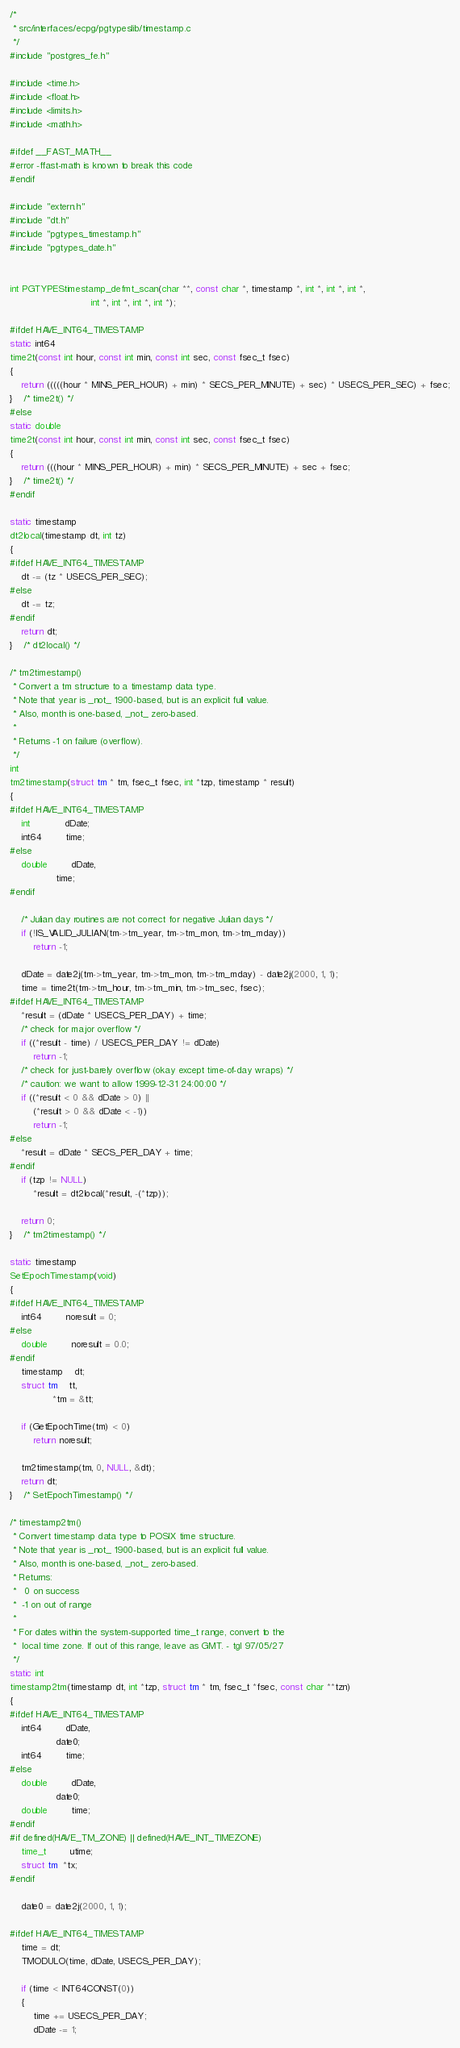<code> <loc_0><loc_0><loc_500><loc_500><_C_>/*
 * src/interfaces/ecpg/pgtypeslib/timestamp.c
 */
#include "postgres_fe.h"

#include <time.h>
#include <float.h>
#include <limits.h>
#include <math.h>

#ifdef __FAST_MATH__
#error -ffast-math is known to break this code
#endif

#include "extern.h"
#include "dt.h"
#include "pgtypes_timestamp.h"
#include "pgtypes_date.h"


int PGTYPEStimestamp_defmt_scan(char **, const char *, timestamp *, int *, int *, int *,
							int *, int *, int *, int *);

#ifdef HAVE_INT64_TIMESTAMP
static int64
time2t(const int hour, const int min, const int sec, const fsec_t fsec)
{
	return (((((hour * MINS_PER_HOUR) + min) * SECS_PER_MINUTE) + sec) * USECS_PER_SEC) + fsec;
}	/* time2t() */
#else
static double
time2t(const int hour, const int min, const int sec, const fsec_t fsec)
{
	return (((hour * MINS_PER_HOUR) + min) * SECS_PER_MINUTE) + sec + fsec;
}	/* time2t() */
#endif

static timestamp
dt2local(timestamp dt, int tz)
{
#ifdef HAVE_INT64_TIMESTAMP
	dt -= (tz * USECS_PER_SEC);
#else
	dt -= tz;
#endif
	return dt;
}	/* dt2local() */

/* tm2timestamp()
 * Convert a tm structure to a timestamp data type.
 * Note that year is _not_ 1900-based, but is an explicit full value.
 * Also, month is one-based, _not_ zero-based.
 *
 * Returns -1 on failure (overflow).
 */
int
tm2timestamp(struct tm * tm, fsec_t fsec, int *tzp, timestamp * result)
{
#ifdef HAVE_INT64_TIMESTAMP
	int			dDate;
	int64		time;
#else
	double		dDate,
				time;
#endif

	/* Julian day routines are not correct for negative Julian days */
	if (!IS_VALID_JULIAN(tm->tm_year, tm->tm_mon, tm->tm_mday))
		return -1;

	dDate = date2j(tm->tm_year, tm->tm_mon, tm->tm_mday) - date2j(2000, 1, 1);
	time = time2t(tm->tm_hour, tm->tm_min, tm->tm_sec, fsec);
#ifdef HAVE_INT64_TIMESTAMP
	*result = (dDate * USECS_PER_DAY) + time;
	/* check for major overflow */
	if ((*result - time) / USECS_PER_DAY != dDate)
		return -1;
	/* check for just-barely overflow (okay except time-of-day wraps) */
	/* caution: we want to allow 1999-12-31 24:00:00 */
	if ((*result < 0 && dDate > 0) ||
		(*result > 0 && dDate < -1))
		return -1;
#else
	*result = dDate * SECS_PER_DAY + time;
#endif
	if (tzp != NULL)
		*result = dt2local(*result, -(*tzp));

	return 0;
}	/* tm2timestamp() */

static timestamp
SetEpochTimestamp(void)
{
#ifdef HAVE_INT64_TIMESTAMP
	int64		noresult = 0;
#else
	double		noresult = 0.0;
#endif
	timestamp	dt;
	struct tm	tt,
			   *tm = &tt;

	if (GetEpochTime(tm) < 0)
		return noresult;

	tm2timestamp(tm, 0, NULL, &dt);
	return dt;
}	/* SetEpochTimestamp() */

/* timestamp2tm()
 * Convert timestamp data type to POSIX time structure.
 * Note that year is _not_ 1900-based, but is an explicit full value.
 * Also, month is one-based, _not_ zero-based.
 * Returns:
 *	 0 on success
 *	-1 on out of range
 *
 * For dates within the system-supported time_t range, convert to the
 *	local time zone. If out of this range, leave as GMT. - tgl 97/05/27
 */
static int
timestamp2tm(timestamp dt, int *tzp, struct tm * tm, fsec_t *fsec, const char **tzn)
{
#ifdef HAVE_INT64_TIMESTAMP
	int64		dDate,
				date0;
	int64		time;
#else
	double		dDate,
				date0;
	double		time;
#endif
#if defined(HAVE_TM_ZONE) || defined(HAVE_INT_TIMEZONE)
	time_t		utime;
	struct tm  *tx;
#endif

	date0 = date2j(2000, 1, 1);

#ifdef HAVE_INT64_TIMESTAMP
	time = dt;
	TMODULO(time, dDate, USECS_PER_DAY);

	if (time < INT64CONST(0))
	{
		time += USECS_PER_DAY;
		dDate -= 1;</code> 